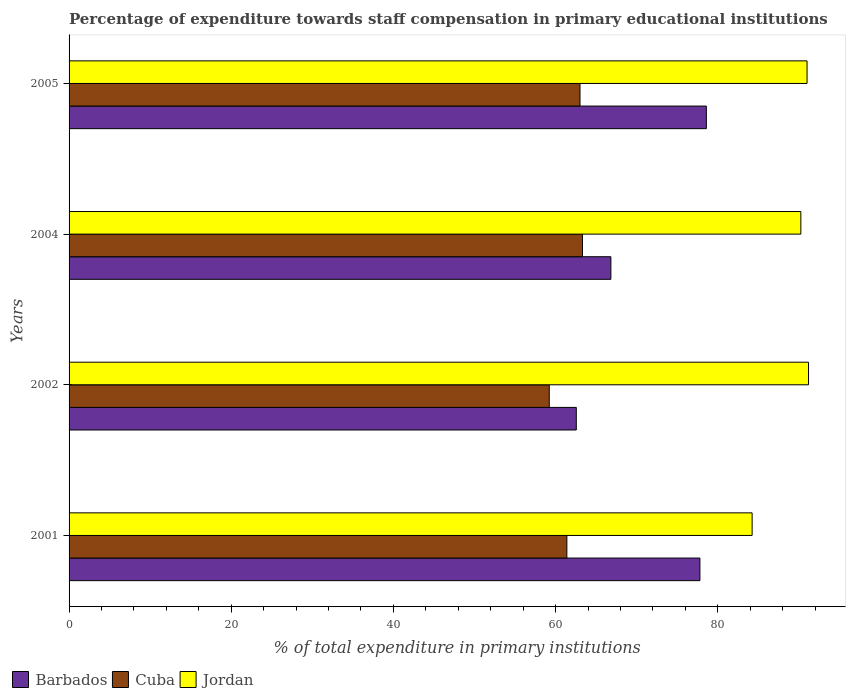How many groups of bars are there?
Your answer should be compact. 4. Are the number of bars per tick equal to the number of legend labels?
Make the answer very short. Yes. How many bars are there on the 4th tick from the top?
Your answer should be compact. 3. What is the label of the 3rd group of bars from the top?
Provide a succinct answer. 2002. In how many cases, is the number of bars for a given year not equal to the number of legend labels?
Offer a terse response. 0. What is the percentage of expenditure towards staff compensation in Jordan in 2002?
Provide a short and direct response. 91.19. Across all years, what is the maximum percentage of expenditure towards staff compensation in Barbados?
Your answer should be compact. 78.59. Across all years, what is the minimum percentage of expenditure towards staff compensation in Jordan?
Ensure brevity in your answer.  84.24. What is the total percentage of expenditure towards staff compensation in Cuba in the graph?
Offer a very short reply. 246.93. What is the difference between the percentage of expenditure towards staff compensation in Cuba in 2002 and that in 2004?
Offer a terse response. -4.1. What is the difference between the percentage of expenditure towards staff compensation in Cuba in 2004 and the percentage of expenditure towards staff compensation in Jordan in 2001?
Your answer should be compact. -20.92. What is the average percentage of expenditure towards staff compensation in Jordan per year?
Your response must be concise. 89.17. In the year 2001, what is the difference between the percentage of expenditure towards staff compensation in Barbados and percentage of expenditure towards staff compensation in Jordan?
Offer a very short reply. -6.44. What is the ratio of the percentage of expenditure towards staff compensation in Cuba in 2002 to that in 2005?
Give a very brief answer. 0.94. Is the difference between the percentage of expenditure towards staff compensation in Barbados in 2001 and 2002 greater than the difference between the percentage of expenditure towards staff compensation in Jordan in 2001 and 2002?
Your response must be concise. Yes. What is the difference between the highest and the second highest percentage of expenditure towards staff compensation in Jordan?
Offer a terse response. 0.18. What is the difference between the highest and the lowest percentage of expenditure towards staff compensation in Cuba?
Ensure brevity in your answer.  4.1. In how many years, is the percentage of expenditure towards staff compensation in Barbados greater than the average percentage of expenditure towards staff compensation in Barbados taken over all years?
Your response must be concise. 2. What does the 1st bar from the top in 2001 represents?
Your answer should be very brief. Jordan. What does the 1st bar from the bottom in 2005 represents?
Ensure brevity in your answer.  Barbados. Is it the case that in every year, the sum of the percentage of expenditure towards staff compensation in Cuba and percentage of expenditure towards staff compensation in Barbados is greater than the percentage of expenditure towards staff compensation in Jordan?
Offer a terse response. Yes. Are all the bars in the graph horizontal?
Keep it short and to the point. Yes. Does the graph contain grids?
Provide a succinct answer. No. Where does the legend appear in the graph?
Offer a very short reply. Bottom left. How are the legend labels stacked?
Offer a terse response. Horizontal. What is the title of the graph?
Your answer should be compact. Percentage of expenditure towards staff compensation in primary educational institutions. Does "Estonia" appear as one of the legend labels in the graph?
Offer a terse response. No. What is the label or title of the X-axis?
Offer a very short reply. % of total expenditure in primary institutions. What is the % of total expenditure in primary institutions in Barbados in 2001?
Give a very brief answer. 77.8. What is the % of total expenditure in primary institutions of Cuba in 2001?
Your response must be concise. 61.39. What is the % of total expenditure in primary institutions of Jordan in 2001?
Offer a very short reply. 84.24. What is the % of total expenditure in primary institutions of Barbados in 2002?
Keep it short and to the point. 62.55. What is the % of total expenditure in primary institutions in Cuba in 2002?
Your answer should be compact. 59.22. What is the % of total expenditure in primary institutions of Jordan in 2002?
Your response must be concise. 91.19. What is the % of total expenditure in primary institutions in Barbados in 2004?
Offer a terse response. 66.82. What is the % of total expenditure in primary institutions in Cuba in 2004?
Keep it short and to the point. 63.31. What is the % of total expenditure in primary institutions of Jordan in 2004?
Ensure brevity in your answer.  90.25. What is the % of total expenditure in primary institutions of Barbados in 2005?
Offer a very short reply. 78.59. What is the % of total expenditure in primary institutions of Cuba in 2005?
Keep it short and to the point. 63.01. What is the % of total expenditure in primary institutions of Jordan in 2005?
Offer a very short reply. 91.01. Across all years, what is the maximum % of total expenditure in primary institutions in Barbados?
Give a very brief answer. 78.59. Across all years, what is the maximum % of total expenditure in primary institutions in Cuba?
Ensure brevity in your answer.  63.31. Across all years, what is the maximum % of total expenditure in primary institutions of Jordan?
Your answer should be compact. 91.19. Across all years, what is the minimum % of total expenditure in primary institutions in Barbados?
Keep it short and to the point. 62.55. Across all years, what is the minimum % of total expenditure in primary institutions in Cuba?
Offer a very short reply. 59.22. Across all years, what is the minimum % of total expenditure in primary institutions in Jordan?
Your response must be concise. 84.24. What is the total % of total expenditure in primary institutions in Barbados in the graph?
Provide a short and direct response. 285.76. What is the total % of total expenditure in primary institutions of Cuba in the graph?
Your answer should be very brief. 246.93. What is the total % of total expenditure in primary institutions in Jordan in the graph?
Offer a very short reply. 356.69. What is the difference between the % of total expenditure in primary institutions in Barbados in 2001 and that in 2002?
Your answer should be very brief. 15.24. What is the difference between the % of total expenditure in primary institutions of Cuba in 2001 and that in 2002?
Provide a short and direct response. 2.17. What is the difference between the % of total expenditure in primary institutions in Jordan in 2001 and that in 2002?
Make the answer very short. -6.96. What is the difference between the % of total expenditure in primary institutions of Barbados in 2001 and that in 2004?
Your response must be concise. 10.98. What is the difference between the % of total expenditure in primary institutions in Cuba in 2001 and that in 2004?
Offer a terse response. -1.92. What is the difference between the % of total expenditure in primary institutions of Jordan in 2001 and that in 2004?
Your answer should be very brief. -6.01. What is the difference between the % of total expenditure in primary institutions in Barbados in 2001 and that in 2005?
Give a very brief answer. -0.8. What is the difference between the % of total expenditure in primary institutions in Cuba in 2001 and that in 2005?
Your answer should be compact. -1.62. What is the difference between the % of total expenditure in primary institutions in Jordan in 2001 and that in 2005?
Your answer should be compact. -6.77. What is the difference between the % of total expenditure in primary institutions of Barbados in 2002 and that in 2004?
Offer a terse response. -4.26. What is the difference between the % of total expenditure in primary institutions of Cuba in 2002 and that in 2004?
Ensure brevity in your answer.  -4.1. What is the difference between the % of total expenditure in primary institutions in Jordan in 2002 and that in 2004?
Provide a succinct answer. 0.95. What is the difference between the % of total expenditure in primary institutions in Barbados in 2002 and that in 2005?
Offer a terse response. -16.04. What is the difference between the % of total expenditure in primary institutions of Cuba in 2002 and that in 2005?
Provide a short and direct response. -3.79. What is the difference between the % of total expenditure in primary institutions in Jordan in 2002 and that in 2005?
Keep it short and to the point. 0.18. What is the difference between the % of total expenditure in primary institutions in Barbados in 2004 and that in 2005?
Your answer should be compact. -11.77. What is the difference between the % of total expenditure in primary institutions of Cuba in 2004 and that in 2005?
Offer a very short reply. 0.3. What is the difference between the % of total expenditure in primary institutions in Jordan in 2004 and that in 2005?
Provide a short and direct response. -0.77. What is the difference between the % of total expenditure in primary institutions in Barbados in 2001 and the % of total expenditure in primary institutions in Cuba in 2002?
Keep it short and to the point. 18.58. What is the difference between the % of total expenditure in primary institutions of Barbados in 2001 and the % of total expenditure in primary institutions of Jordan in 2002?
Provide a short and direct response. -13.4. What is the difference between the % of total expenditure in primary institutions of Cuba in 2001 and the % of total expenditure in primary institutions of Jordan in 2002?
Provide a succinct answer. -29.8. What is the difference between the % of total expenditure in primary institutions in Barbados in 2001 and the % of total expenditure in primary institutions in Cuba in 2004?
Your response must be concise. 14.48. What is the difference between the % of total expenditure in primary institutions of Barbados in 2001 and the % of total expenditure in primary institutions of Jordan in 2004?
Your answer should be compact. -12.45. What is the difference between the % of total expenditure in primary institutions of Cuba in 2001 and the % of total expenditure in primary institutions of Jordan in 2004?
Offer a terse response. -28.86. What is the difference between the % of total expenditure in primary institutions of Barbados in 2001 and the % of total expenditure in primary institutions of Cuba in 2005?
Give a very brief answer. 14.79. What is the difference between the % of total expenditure in primary institutions of Barbados in 2001 and the % of total expenditure in primary institutions of Jordan in 2005?
Make the answer very short. -13.21. What is the difference between the % of total expenditure in primary institutions in Cuba in 2001 and the % of total expenditure in primary institutions in Jordan in 2005?
Give a very brief answer. -29.62. What is the difference between the % of total expenditure in primary institutions of Barbados in 2002 and the % of total expenditure in primary institutions of Cuba in 2004?
Ensure brevity in your answer.  -0.76. What is the difference between the % of total expenditure in primary institutions of Barbados in 2002 and the % of total expenditure in primary institutions of Jordan in 2004?
Provide a succinct answer. -27.69. What is the difference between the % of total expenditure in primary institutions in Cuba in 2002 and the % of total expenditure in primary institutions in Jordan in 2004?
Provide a succinct answer. -31.03. What is the difference between the % of total expenditure in primary institutions in Barbados in 2002 and the % of total expenditure in primary institutions in Cuba in 2005?
Offer a terse response. -0.46. What is the difference between the % of total expenditure in primary institutions of Barbados in 2002 and the % of total expenditure in primary institutions of Jordan in 2005?
Offer a very short reply. -28.46. What is the difference between the % of total expenditure in primary institutions of Cuba in 2002 and the % of total expenditure in primary institutions of Jordan in 2005?
Keep it short and to the point. -31.79. What is the difference between the % of total expenditure in primary institutions in Barbados in 2004 and the % of total expenditure in primary institutions in Cuba in 2005?
Offer a terse response. 3.81. What is the difference between the % of total expenditure in primary institutions in Barbados in 2004 and the % of total expenditure in primary institutions in Jordan in 2005?
Make the answer very short. -24.19. What is the difference between the % of total expenditure in primary institutions of Cuba in 2004 and the % of total expenditure in primary institutions of Jordan in 2005?
Offer a terse response. -27.7. What is the average % of total expenditure in primary institutions of Barbados per year?
Ensure brevity in your answer.  71.44. What is the average % of total expenditure in primary institutions in Cuba per year?
Make the answer very short. 61.73. What is the average % of total expenditure in primary institutions of Jordan per year?
Give a very brief answer. 89.17. In the year 2001, what is the difference between the % of total expenditure in primary institutions in Barbados and % of total expenditure in primary institutions in Cuba?
Offer a terse response. 16.41. In the year 2001, what is the difference between the % of total expenditure in primary institutions of Barbados and % of total expenditure in primary institutions of Jordan?
Your response must be concise. -6.44. In the year 2001, what is the difference between the % of total expenditure in primary institutions in Cuba and % of total expenditure in primary institutions in Jordan?
Offer a very short reply. -22.85. In the year 2002, what is the difference between the % of total expenditure in primary institutions of Barbados and % of total expenditure in primary institutions of Cuba?
Your answer should be compact. 3.34. In the year 2002, what is the difference between the % of total expenditure in primary institutions in Barbados and % of total expenditure in primary institutions in Jordan?
Ensure brevity in your answer.  -28.64. In the year 2002, what is the difference between the % of total expenditure in primary institutions of Cuba and % of total expenditure in primary institutions of Jordan?
Provide a short and direct response. -31.98. In the year 2004, what is the difference between the % of total expenditure in primary institutions of Barbados and % of total expenditure in primary institutions of Cuba?
Provide a succinct answer. 3.51. In the year 2004, what is the difference between the % of total expenditure in primary institutions in Barbados and % of total expenditure in primary institutions in Jordan?
Your answer should be compact. -23.43. In the year 2004, what is the difference between the % of total expenditure in primary institutions of Cuba and % of total expenditure in primary institutions of Jordan?
Keep it short and to the point. -26.93. In the year 2005, what is the difference between the % of total expenditure in primary institutions in Barbados and % of total expenditure in primary institutions in Cuba?
Provide a succinct answer. 15.58. In the year 2005, what is the difference between the % of total expenditure in primary institutions of Barbados and % of total expenditure in primary institutions of Jordan?
Give a very brief answer. -12.42. In the year 2005, what is the difference between the % of total expenditure in primary institutions in Cuba and % of total expenditure in primary institutions in Jordan?
Offer a very short reply. -28. What is the ratio of the % of total expenditure in primary institutions of Barbados in 2001 to that in 2002?
Make the answer very short. 1.24. What is the ratio of the % of total expenditure in primary institutions in Cuba in 2001 to that in 2002?
Make the answer very short. 1.04. What is the ratio of the % of total expenditure in primary institutions of Jordan in 2001 to that in 2002?
Your answer should be very brief. 0.92. What is the ratio of the % of total expenditure in primary institutions of Barbados in 2001 to that in 2004?
Your response must be concise. 1.16. What is the ratio of the % of total expenditure in primary institutions in Cuba in 2001 to that in 2004?
Make the answer very short. 0.97. What is the ratio of the % of total expenditure in primary institutions of Jordan in 2001 to that in 2004?
Keep it short and to the point. 0.93. What is the ratio of the % of total expenditure in primary institutions of Barbados in 2001 to that in 2005?
Your answer should be compact. 0.99. What is the ratio of the % of total expenditure in primary institutions of Cuba in 2001 to that in 2005?
Provide a short and direct response. 0.97. What is the ratio of the % of total expenditure in primary institutions in Jordan in 2001 to that in 2005?
Offer a very short reply. 0.93. What is the ratio of the % of total expenditure in primary institutions in Barbados in 2002 to that in 2004?
Give a very brief answer. 0.94. What is the ratio of the % of total expenditure in primary institutions in Cuba in 2002 to that in 2004?
Give a very brief answer. 0.94. What is the ratio of the % of total expenditure in primary institutions of Jordan in 2002 to that in 2004?
Give a very brief answer. 1.01. What is the ratio of the % of total expenditure in primary institutions in Barbados in 2002 to that in 2005?
Your answer should be very brief. 0.8. What is the ratio of the % of total expenditure in primary institutions of Cuba in 2002 to that in 2005?
Provide a succinct answer. 0.94. What is the ratio of the % of total expenditure in primary institutions of Jordan in 2002 to that in 2005?
Offer a very short reply. 1. What is the ratio of the % of total expenditure in primary institutions in Barbados in 2004 to that in 2005?
Offer a terse response. 0.85. What is the ratio of the % of total expenditure in primary institutions of Cuba in 2004 to that in 2005?
Offer a very short reply. 1. What is the ratio of the % of total expenditure in primary institutions of Jordan in 2004 to that in 2005?
Give a very brief answer. 0.99. What is the difference between the highest and the second highest % of total expenditure in primary institutions in Barbados?
Offer a very short reply. 0.8. What is the difference between the highest and the second highest % of total expenditure in primary institutions in Cuba?
Keep it short and to the point. 0.3. What is the difference between the highest and the second highest % of total expenditure in primary institutions in Jordan?
Your answer should be very brief. 0.18. What is the difference between the highest and the lowest % of total expenditure in primary institutions of Barbados?
Provide a short and direct response. 16.04. What is the difference between the highest and the lowest % of total expenditure in primary institutions of Cuba?
Ensure brevity in your answer.  4.1. What is the difference between the highest and the lowest % of total expenditure in primary institutions of Jordan?
Offer a very short reply. 6.96. 